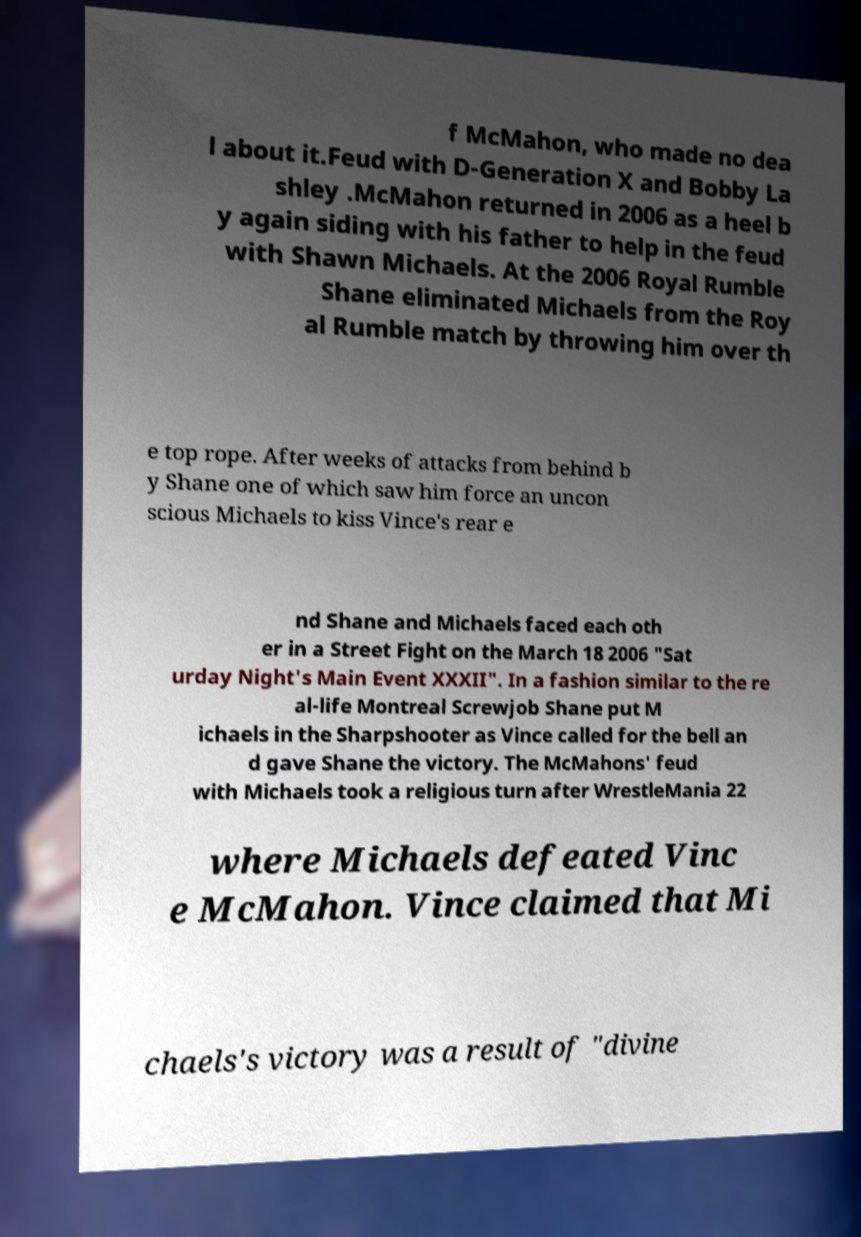Can you read and provide the text displayed in the image?This photo seems to have some interesting text. Can you extract and type it out for me? f McMahon, who made no dea l about it.Feud with D-Generation X and Bobby La shley .McMahon returned in 2006 as a heel b y again siding with his father to help in the feud with Shawn Michaels. At the 2006 Royal Rumble Shane eliminated Michaels from the Roy al Rumble match by throwing him over th e top rope. After weeks of attacks from behind b y Shane one of which saw him force an uncon scious Michaels to kiss Vince's rear e nd Shane and Michaels faced each oth er in a Street Fight on the March 18 2006 "Sat urday Night's Main Event XXXII". In a fashion similar to the re al-life Montreal Screwjob Shane put M ichaels in the Sharpshooter as Vince called for the bell an d gave Shane the victory. The McMahons' feud with Michaels took a religious turn after WrestleMania 22 where Michaels defeated Vinc e McMahon. Vince claimed that Mi chaels's victory was a result of "divine 